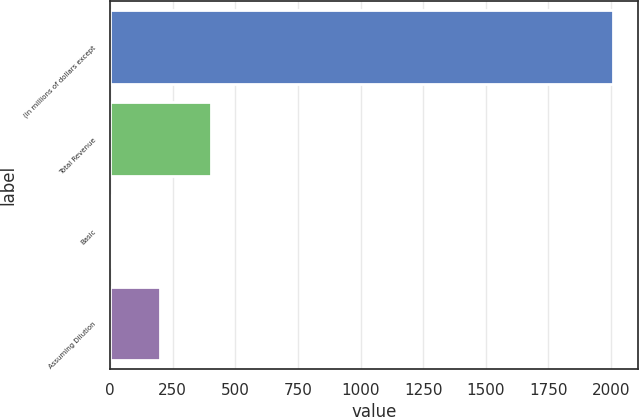Convert chart to OTSL. <chart><loc_0><loc_0><loc_500><loc_500><bar_chart><fcel>(in millions of dollars except<fcel>Total Revenue<fcel>Basic<fcel>Assuming Dilution<nl><fcel>2007<fcel>401.42<fcel>0.02<fcel>200.72<nl></chart> 